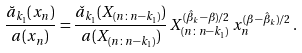Convert formula to latex. <formula><loc_0><loc_0><loc_500><loc_500>\frac { \breve { a } _ { k _ { 1 } } ( x _ { n } ) } { a ( x _ { n } ) } = \frac { \check { a } _ { k _ { 1 } } ( X _ { ( n \colon n - k _ { 1 } ) } ) } { a ( X _ { ( n \colon n - k _ { 1 } ) } ) } \, X _ { ( n \colon n - k _ { 1 } ) } ^ { ( \hat { \beta } _ { k } - \beta ) / 2 } \, x _ { n } ^ { ( \beta - \hat { \beta } _ { k } ) / 2 } \, .</formula> 